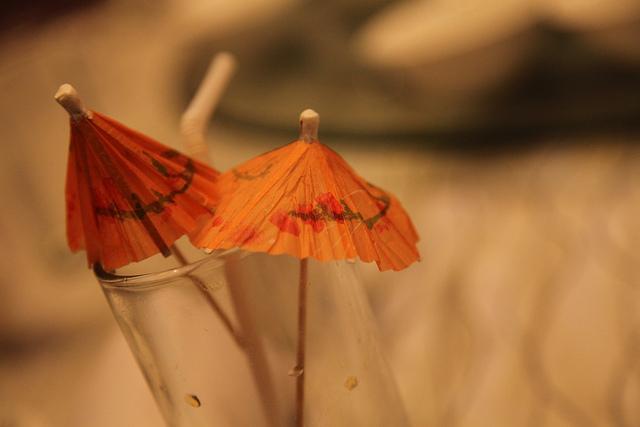Is the straw flexible?
Be succinct. Yes. What is in the glass?
Concise answer only. Umbrellas. What colors are the umbrellas?
Answer briefly. Orange. What type of glasses are those?
Short answer required. Drinking. 